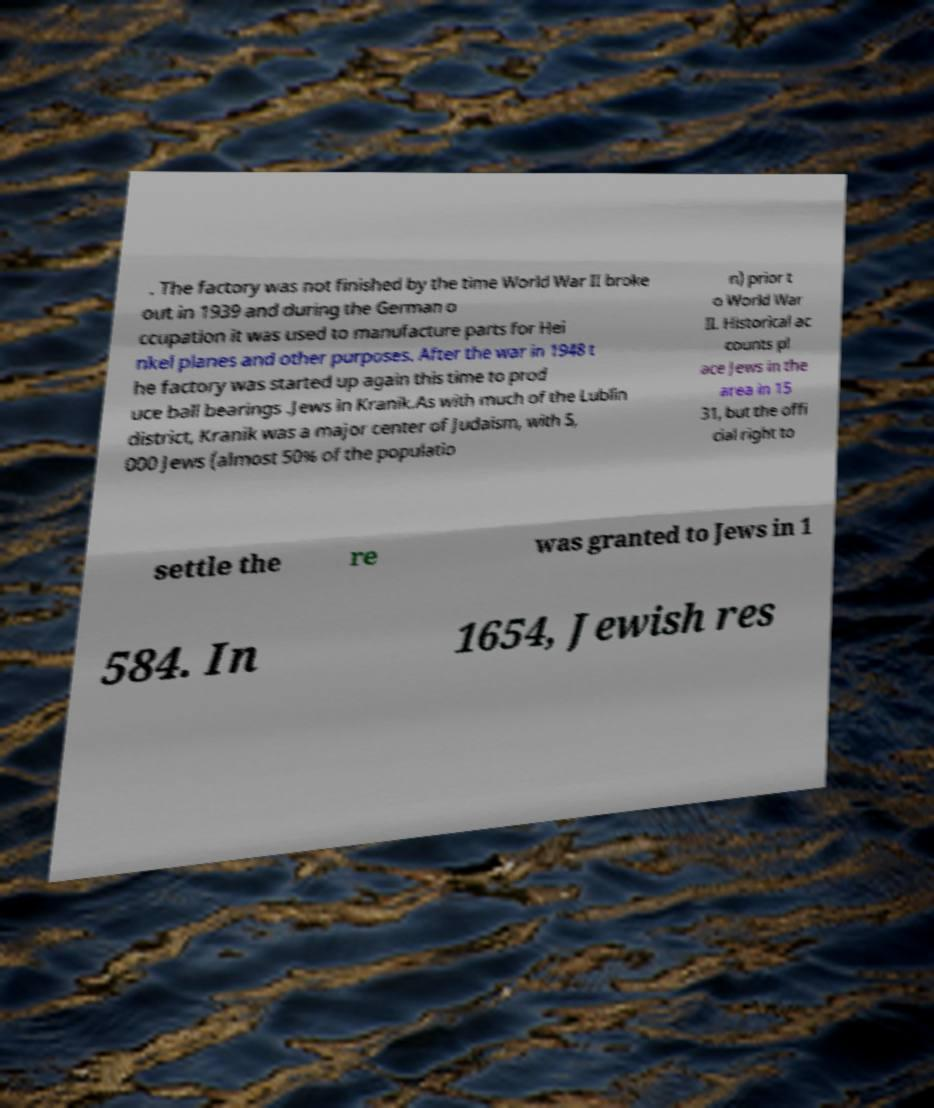There's text embedded in this image that I need extracted. Can you transcribe it verbatim? . The factory was not finished by the time World War II broke out in 1939 and during the German o ccupation it was used to manufacture parts for Hei nkel planes and other purposes. After the war in 1948 t he factory was started up again this time to prod uce ball bearings .Jews in Kranik.As with much of the Lublin district, Kranik was a major center of Judaism, with 5, 000 Jews (almost 50% of the populatio n) prior t o World War II. Historical ac counts pl ace Jews in the area in 15 31, but the offi cial right to settle the re was granted to Jews in 1 584. In 1654, Jewish res 